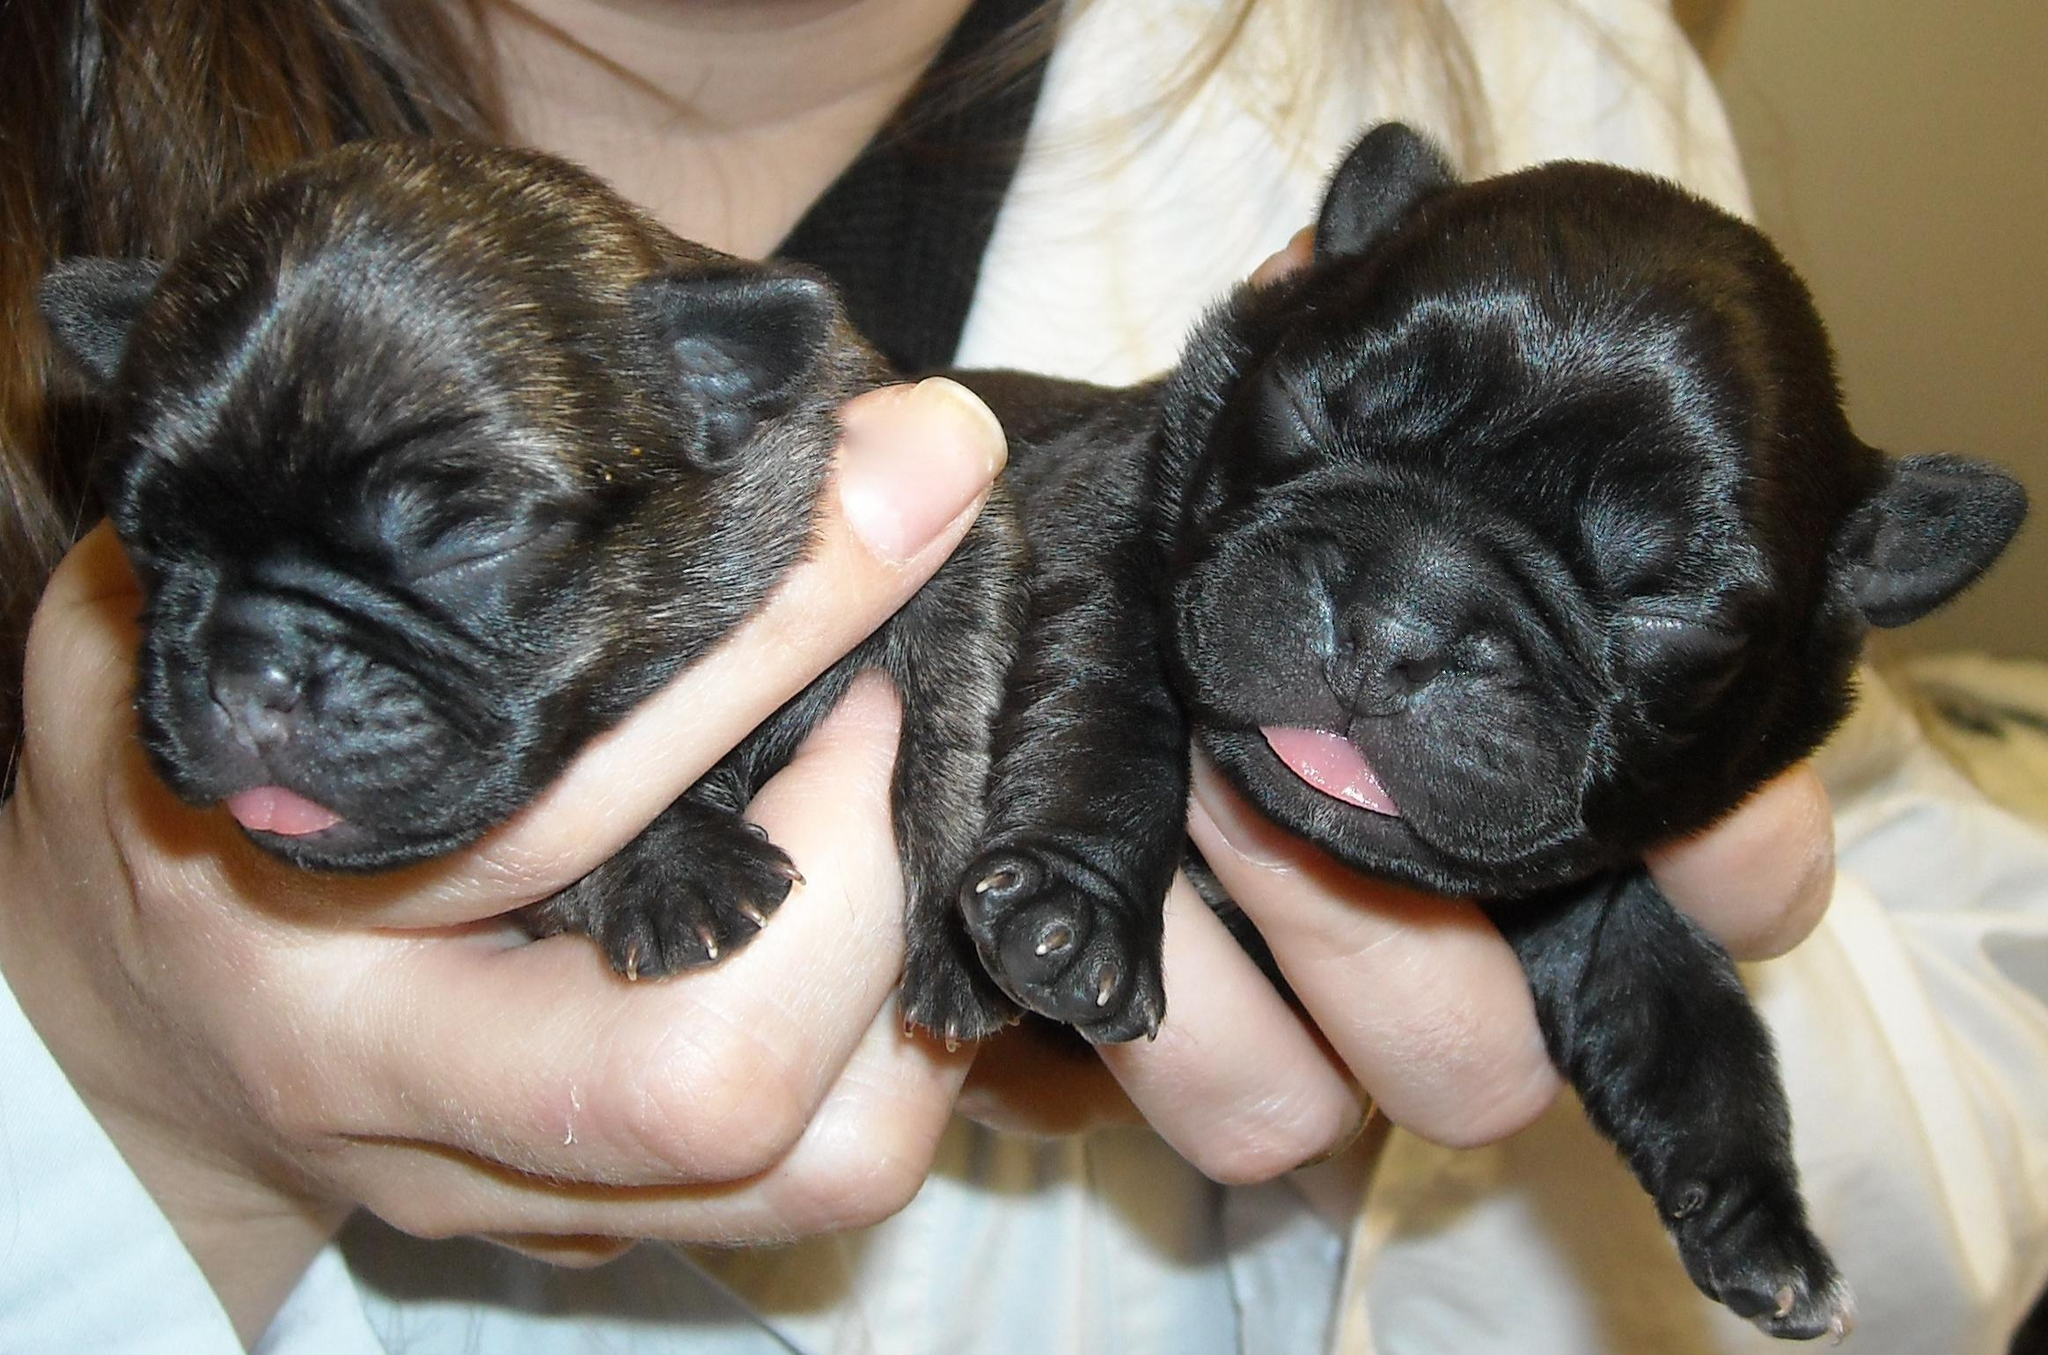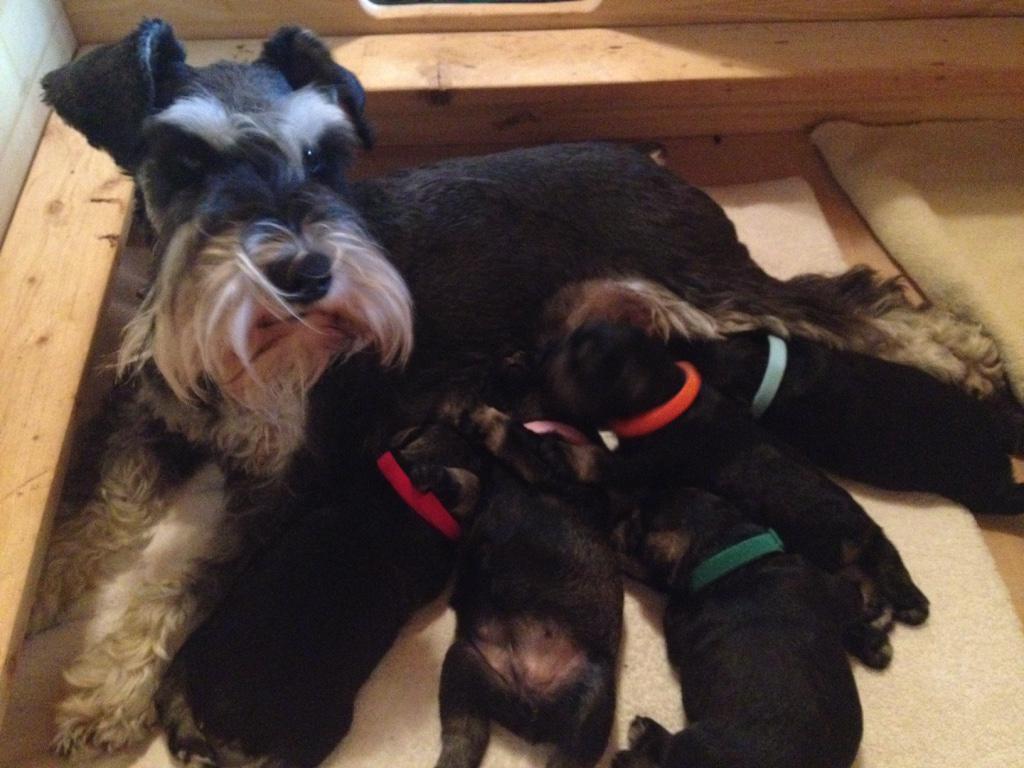The first image is the image on the left, the second image is the image on the right. Given the left and right images, does the statement "At least one puppy has white hair around it's mouth." hold true? Answer yes or no. No. 